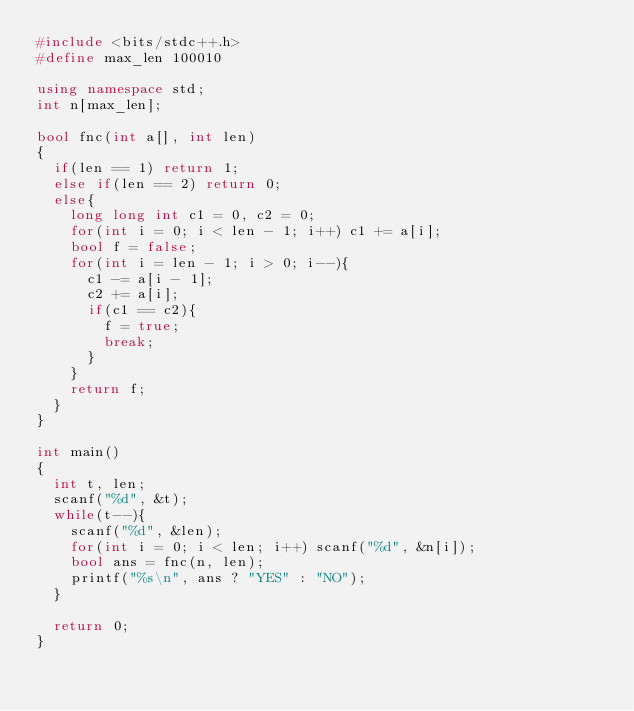<code> <loc_0><loc_0><loc_500><loc_500><_C++_>#include <bits/stdc++.h>
#define max_len 100010

using namespace std;
int n[max_len];

bool fnc(int a[], int len)
{
  if(len == 1) return 1;
  else if(len == 2) return 0;
  else{
    long long int c1 = 0, c2 = 0;
    for(int i = 0; i < len - 1; i++) c1 += a[i];
    bool f = false;
    for(int i = len - 1; i > 0; i--){
      c1 -= a[i - 1];
      c2 += a[i];
      if(c1 == c2){
        f = true;
        break;
      }
    }
    return f;
  }
}

int main()
{
  int t, len;
  scanf("%d", &t);
  while(t--){
    scanf("%d", &len);
    for(int i = 0; i < len; i++) scanf("%d", &n[i]);
    bool ans = fnc(n, len);
    printf("%s\n", ans ? "YES" : "NO");
  }
  
  return 0;
}</code> 